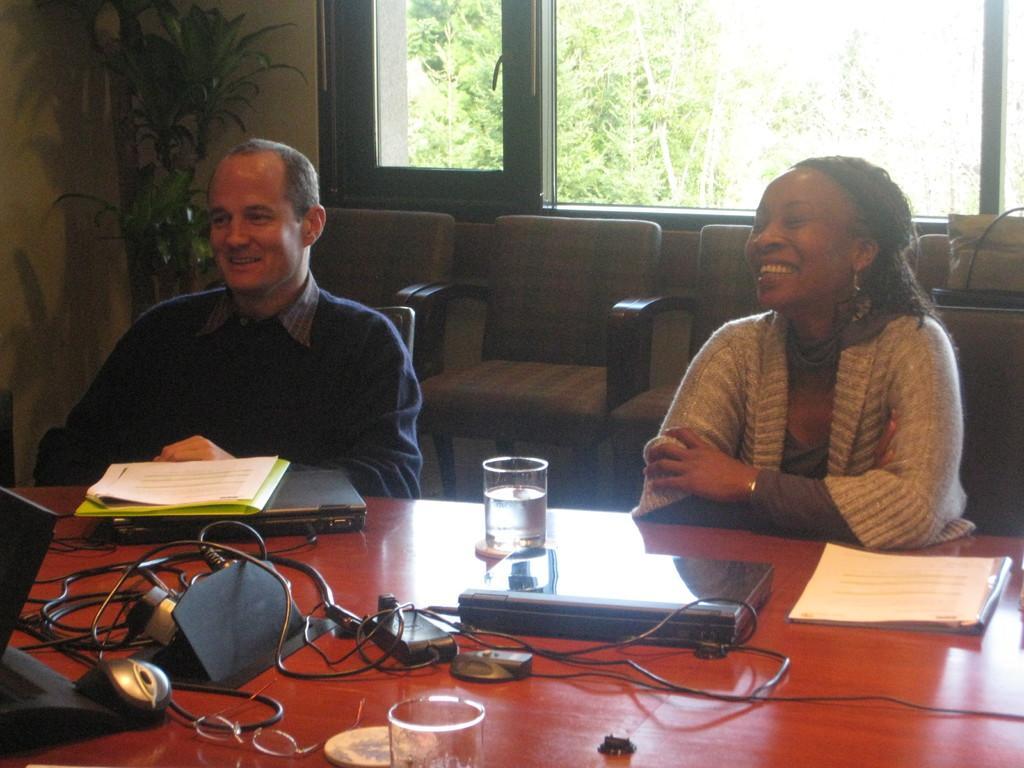How would you summarize this image in a sentence or two? In this picture, there is a man and a woman, sitting in the chairs in front of a table. On the table there are laptops, papers, files and a glass. In the background there are some chairs, plants and some trees here. 